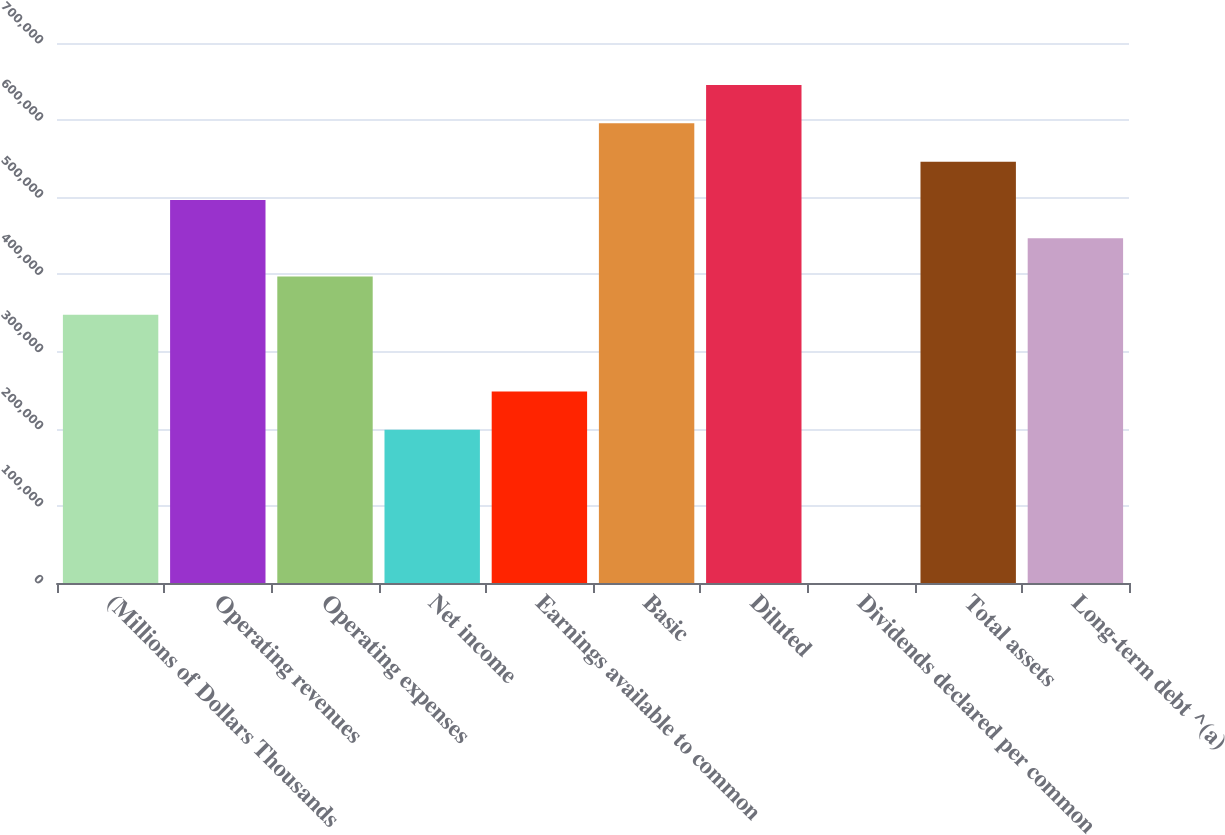Convert chart to OTSL. <chart><loc_0><loc_0><loc_500><loc_500><bar_chart><fcel>(Millions of Dollars Thousands<fcel>Operating revenues<fcel>Operating expenses<fcel>Net income<fcel>Earnings available to common<fcel>Basic<fcel>Diluted<fcel>Dividends declared per common<fcel>Total assets<fcel>Long-term debt ^(a)<nl><fcel>347573<fcel>496532<fcel>397226<fcel>198613<fcel>248267<fcel>595838<fcel>645491<fcel>1.11<fcel>546185<fcel>446879<nl></chart> 